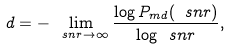<formula> <loc_0><loc_0><loc_500><loc_500>d = - \lim _ { \ s n r \rightarrow \infty } \frac { \log P _ { m d } ( \ s n r ) } { \log \ s n r } ,</formula> 